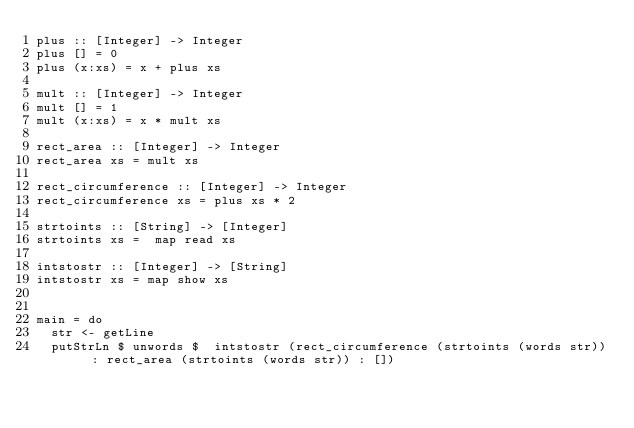Convert code to text. <code><loc_0><loc_0><loc_500><loc_500><_Haskell_>plus :: [Integer] -> Integer
plus [] = 0
plus (x:xs) = x + plus xs

mult :: [Integer] -> Integer
mult [] = 1
mult (x:xs) = x * mult xs

rect_area :: [Integer] -> Integer
rect_area xs = mult xs

rect_circumference :: [Integer] -> Integer
rect_circumference xs = plus xs * 2

strtoints :: [String] -> [Integer]
strtoints xs =  map read xs

intstostr :: [Integer] -> [String]
intstostr xs = map show xs


main = do
  str <- getLine
  putStrLn $ unwords $  intstostr (rect_circumference (strtoints (words str)) : rect_area (strtoints (words str)) : [])</code> 